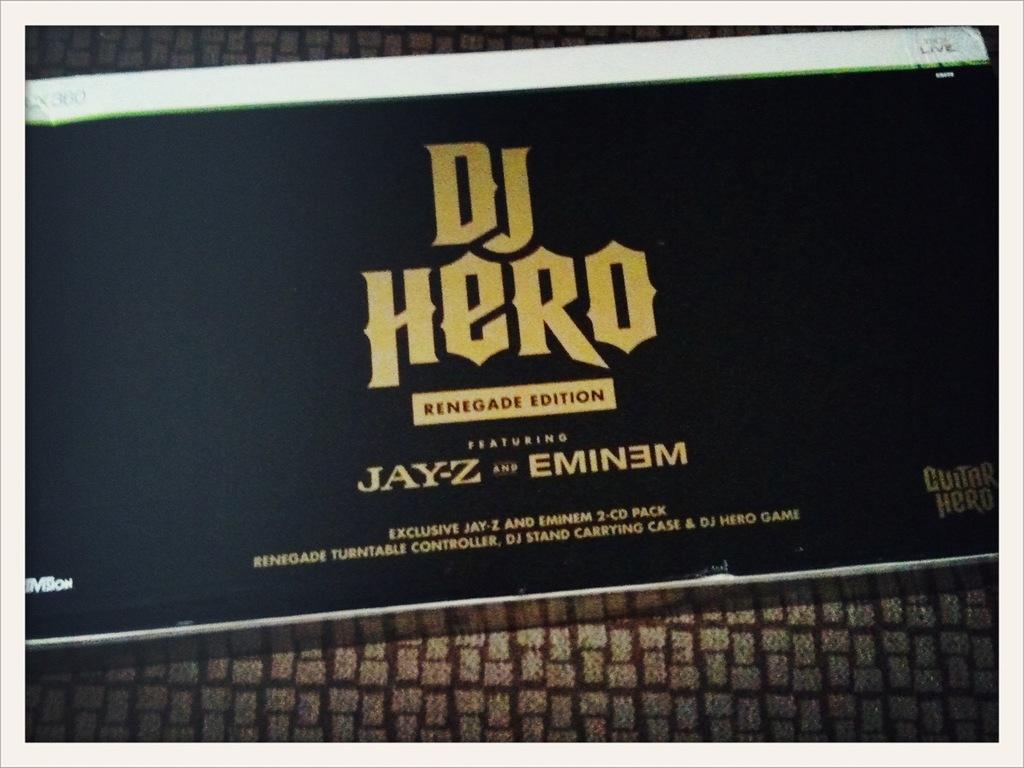How many items are in this product?
Keep it short and to the point. 2. 